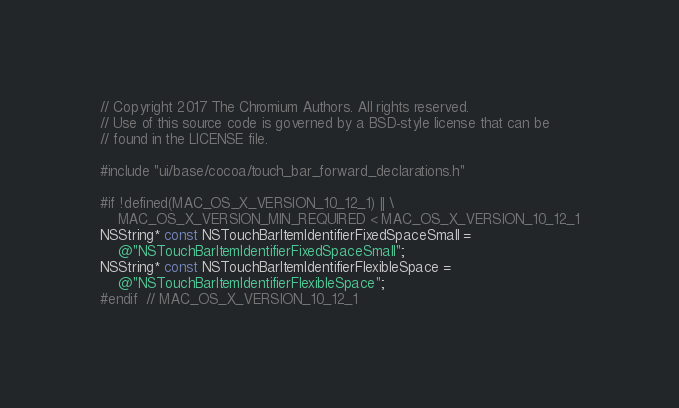Convert code to text. <code><loc_0><loc_0><loc_500><loc_500><_ObjectiveC_>// Copyright 2017 The Chromium Authors. All rights reserved.
// Use of this source code is governed by a BSD-style license that can be
// found in the LICENSE file.

#include "ui/base/cocoa/touch_bar_forward_declarations.h"

#if !defined(MAC_OS_X_VERSION_10_12_1) || \
    MAC_OS_X_VERSION_MIN_REQUIRED < MAC_OS_X_VERSION_10_12_1
NSString* const NSTouchBarItemIdentifierFixedSpaceSmall =
    @"NSTouchBarItemIdentifierFixedSpaceSmall";
NSString* const NSTouchBarItemIdentifierFlexibleSpace =
    @"NSTouchBarItemIdentifierFlexibleSpace";
#endif  // MAC_OS_X_VERSION_10_12_1
</code> 